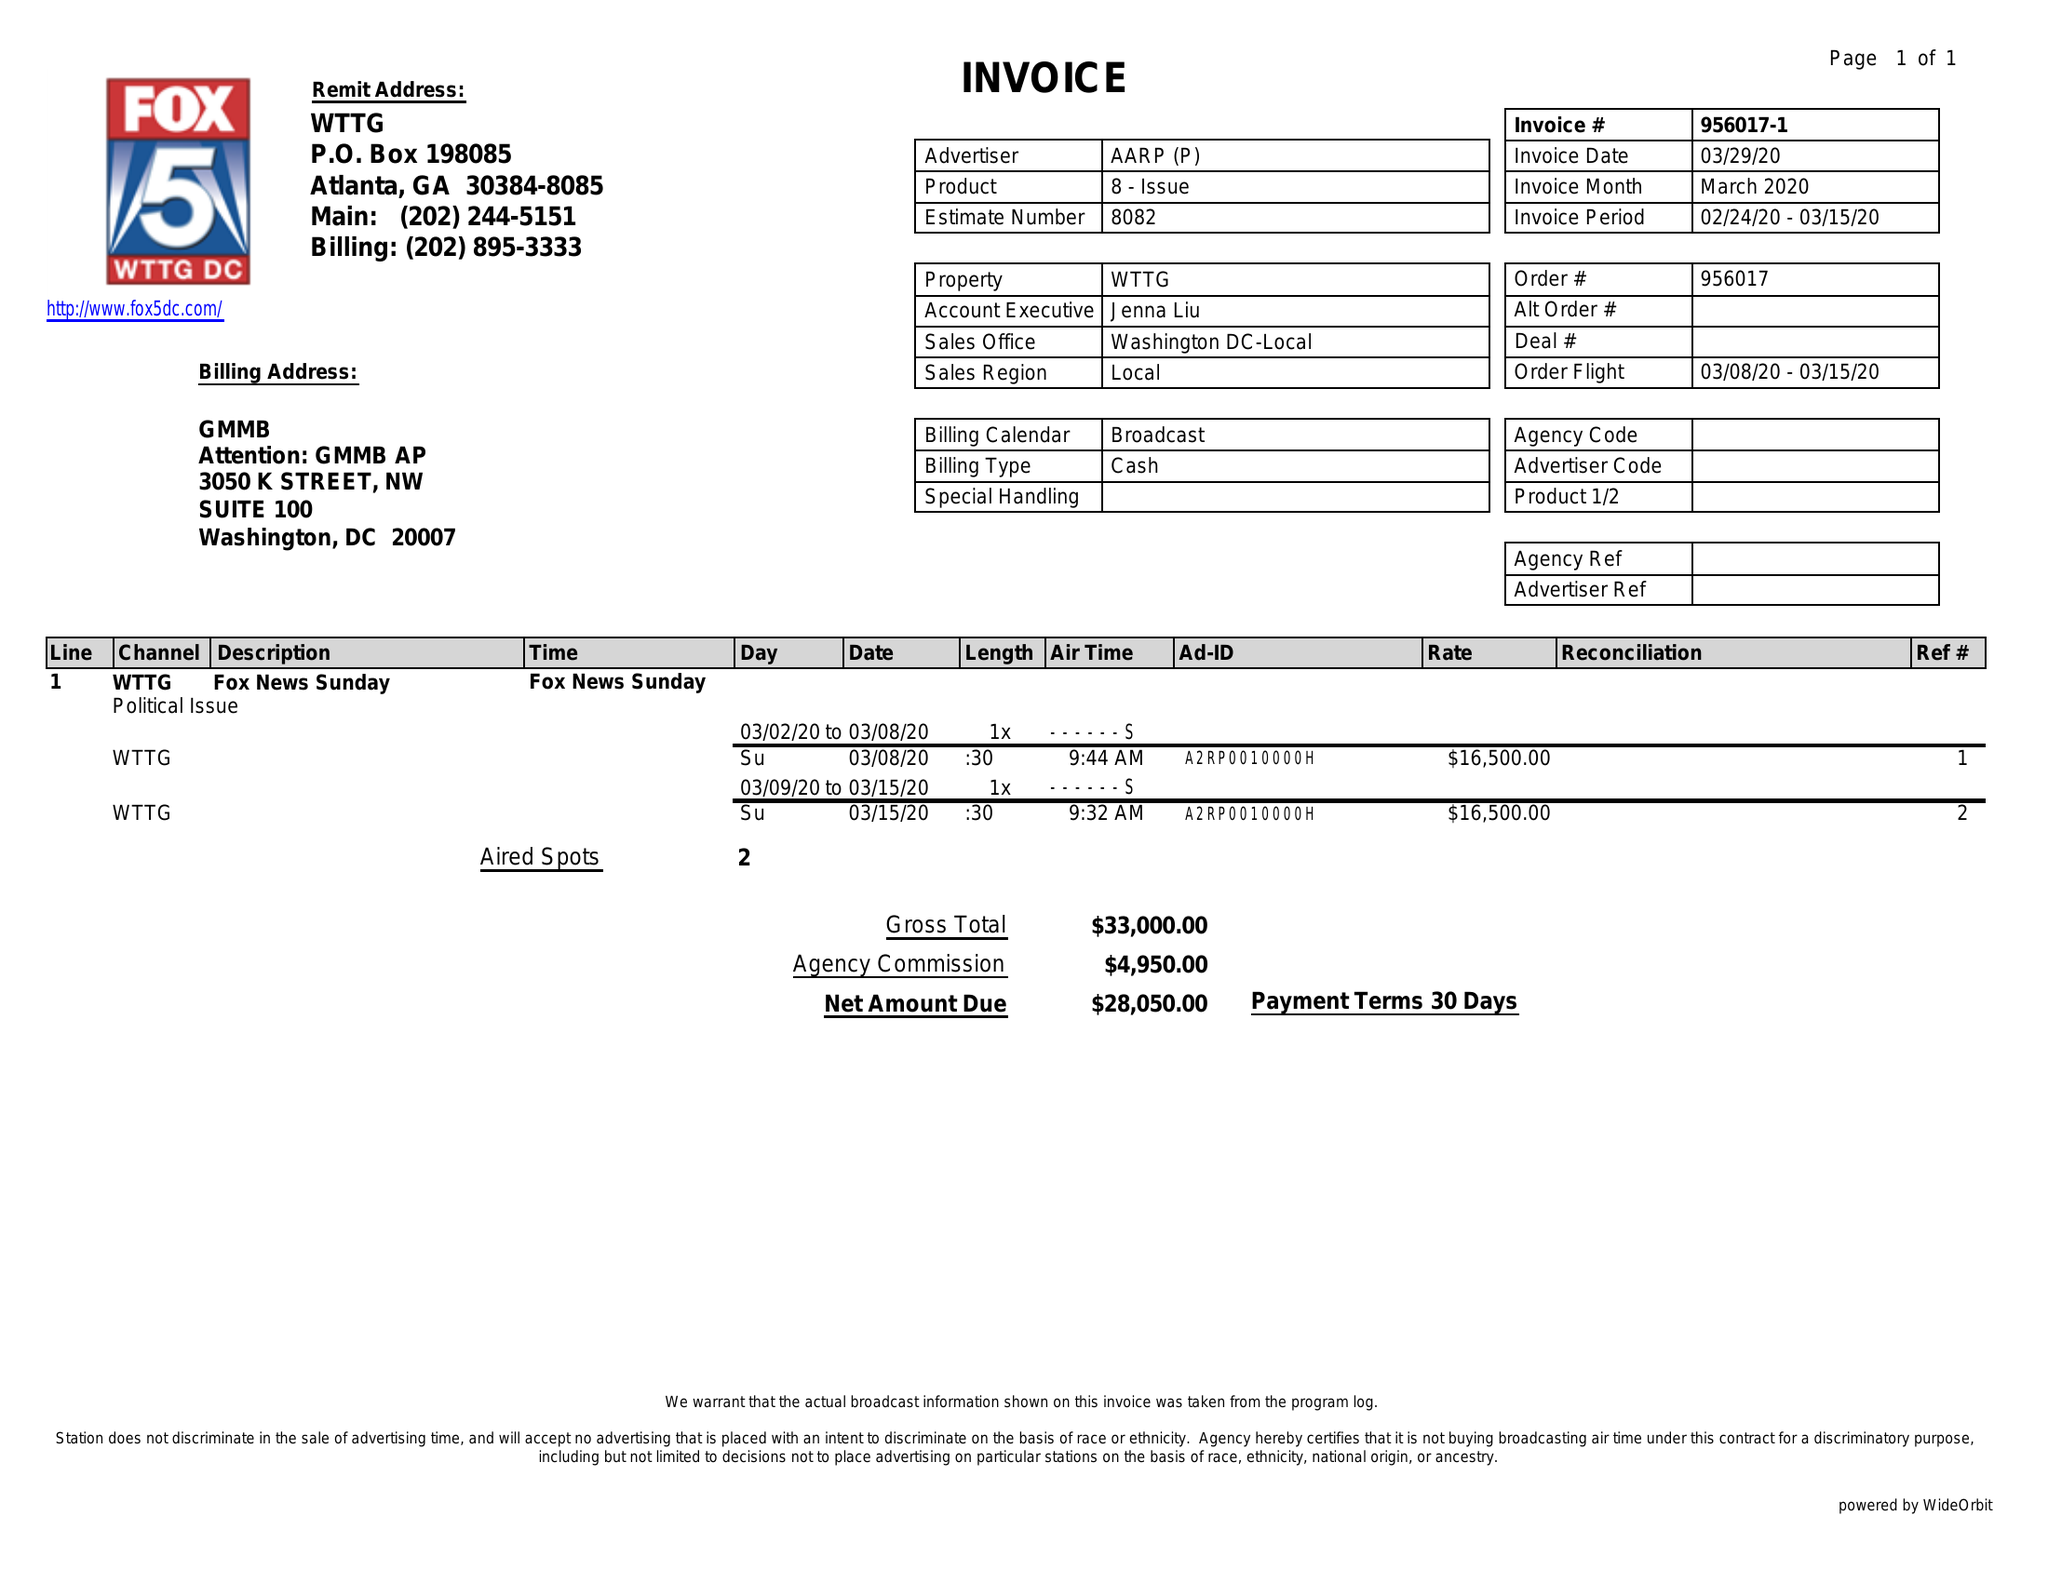What is the value for the contract_num?
Answer the question using a single word or phrase. 956017 